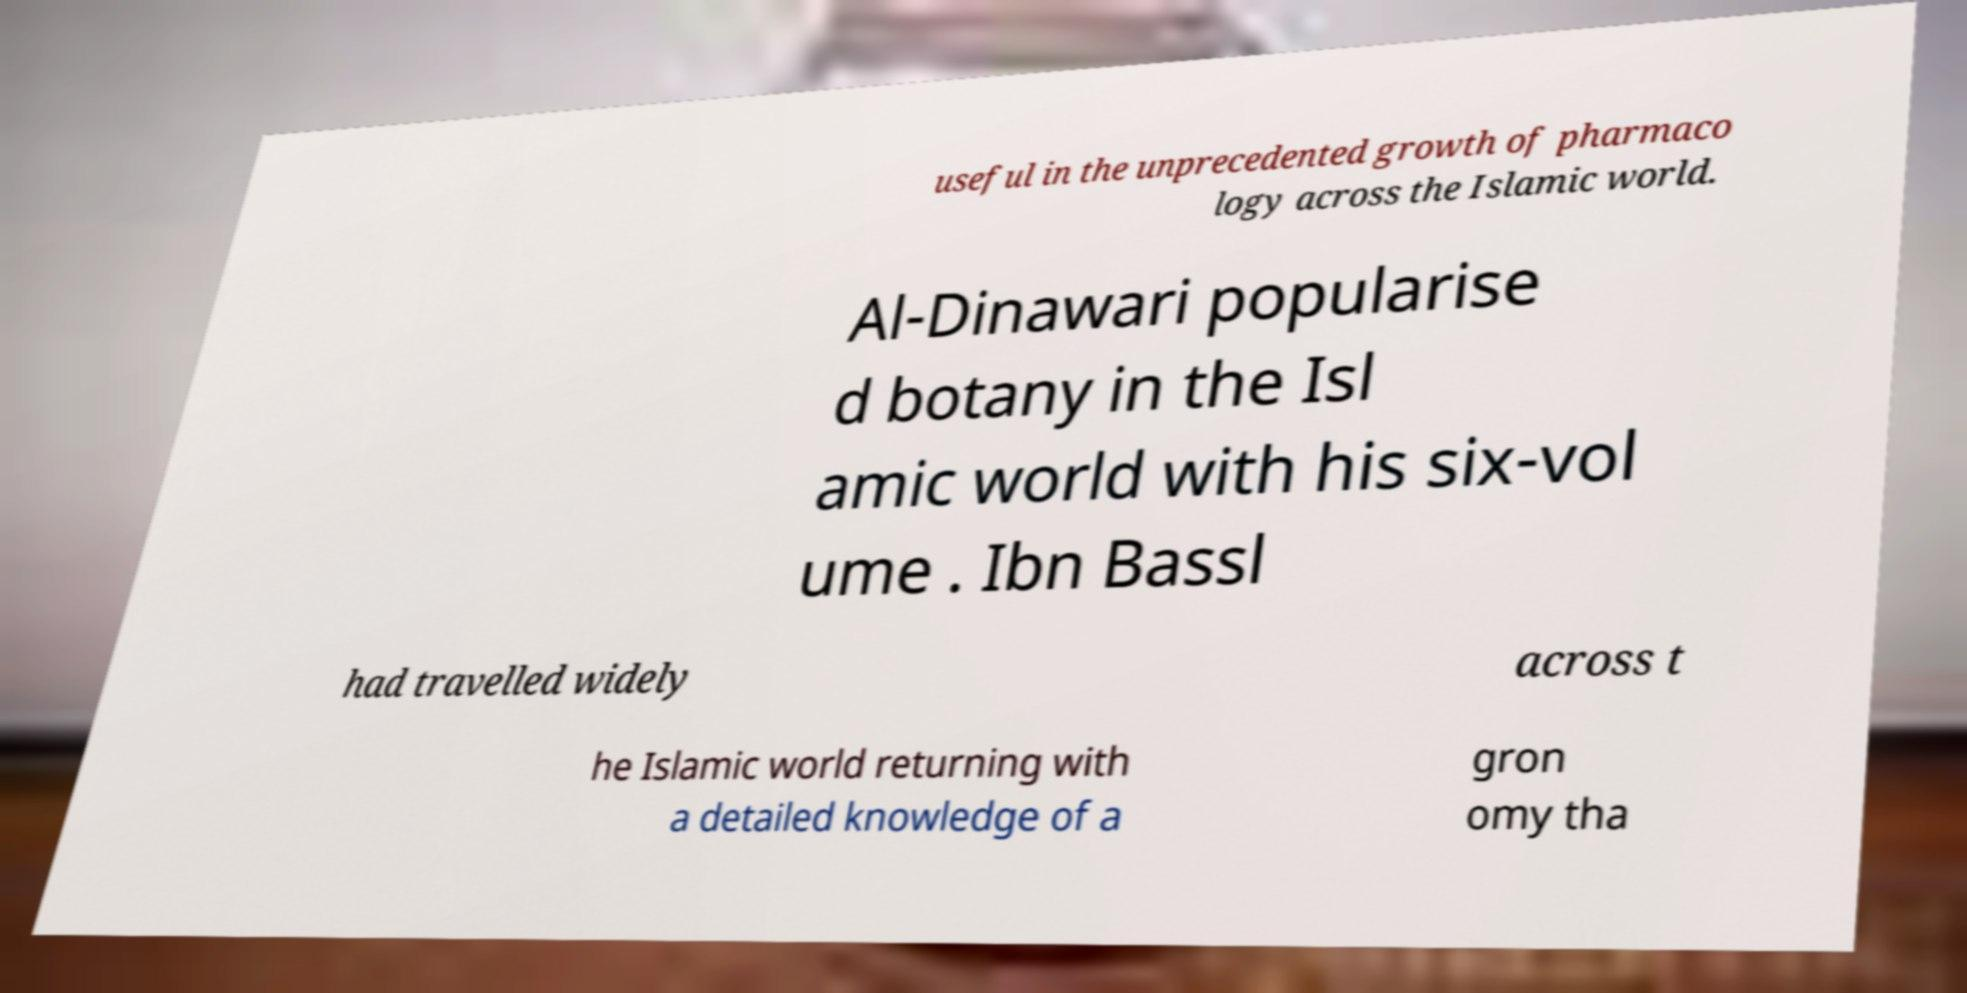Please identify and transcribe the text found in this image. useful in the unprecedented growth of pharmaco logy across the Islamic world. Al-Dinawari popularise d botany in the Isl amic world with his six-vol ume . Ibn Bassl had travelled widely across t he Islamic world returning with a detailed knowledge of a gron omy tha 